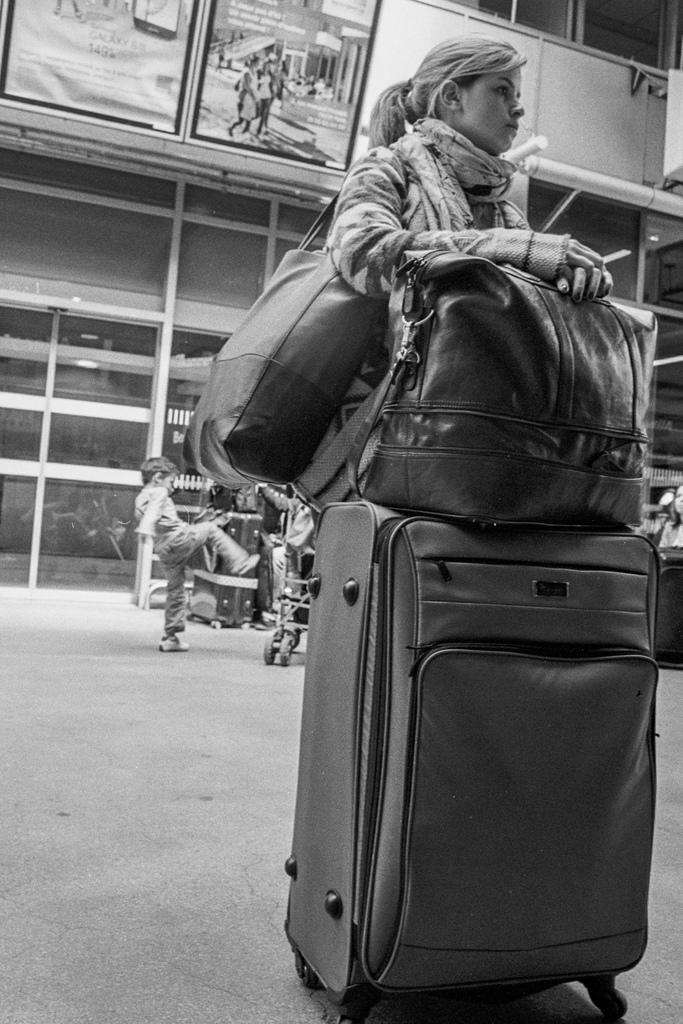How would you summarize this image in a sentence or two? In this image I see a woman who is carrying a bag and there are luggage in front of her. In the background I see a child. 